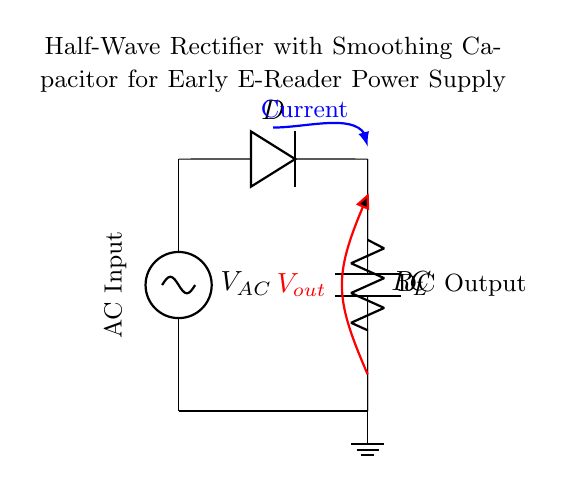What is the type of rectifier shown in the circuit? The circuit diagram depicts a half-wave rectifier, which only allows one half of the AC voltage waveform through.
Answer: half-wave rectifier What component converts AC to DC in this circuit? The diode in the circuit allows current to flow in only one direction, thus converting AC to DC.
Answer: diode What is the purpose of the smoothing capacitor in this design? The smoothing capacitor reduces the ripples in the DC output voltage by storing charge and releasing it when the voltage dips.
Answer: smoothing What is the function of the load resistor in this circuit? The load resistor, labeled as R_L, serves as the component that consumes the output power from the rectifier circuit.
Answer: consumes power What is the effect of increasing the value of the smoothing capacitor? Increasing the capacitance would further reduce the ripple voltage on the output, leading to a more stable DC output voltage.
Answer: reduces ripple How does the current flow in this half-wave rectifier circuit? Current flows through the AC source, passes through the diode (when it is forward-biased), and charges the capacitor, providing a path to the load resistor.
Answer: flows to load What is the output voltage represented in the circuit? The output voltage V_out is shown connecting the load resistor to the smoothing capacitor, indicating the voltage available across them.
Answer: V_out 